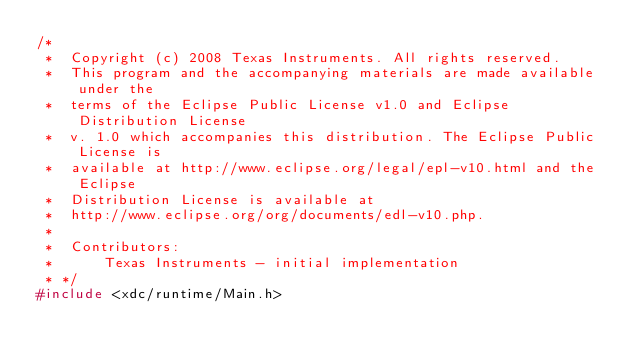Convert code to text. <code><loc_0><loc_0><loc_500><loc_500><_C_>/* 
 *  Copyright (c) 2008 Texas Instruments. All rights reserved. 
 *  This program and the accompanying materials are made available under the 
 *  terms of the Eclipse Public License v1.0 and Eclipse Distribution License
 *  v. 1.0 which accompanies this distribution. The Eclipse Public License is
 *  available at http://www.eclipse.org/legal/epl-v10.html and the Eclipse
 *  Distribution License is available at 
 *  http://www.eclipse.org/org/documents/edl-v10.php.
 *
 *  Contributors:
 *      Texas Instruments - initial implementation
 * */
#include <xdc/runtime/Main.h>
</code> 